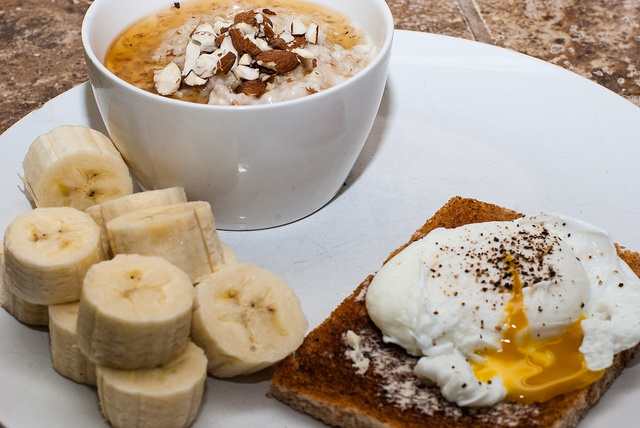Describe the objects in this image and their specific colors. I can see dining table in gray, lightgray, and darkgray tones, cake in gray, lightgray, maroon, darkgray, and olive tones, bowl in gray, darkgray, lightgray, and tan tones, banana in gray, olive, and tan tones, and banana in gray, tan, and olive tones in this image. 